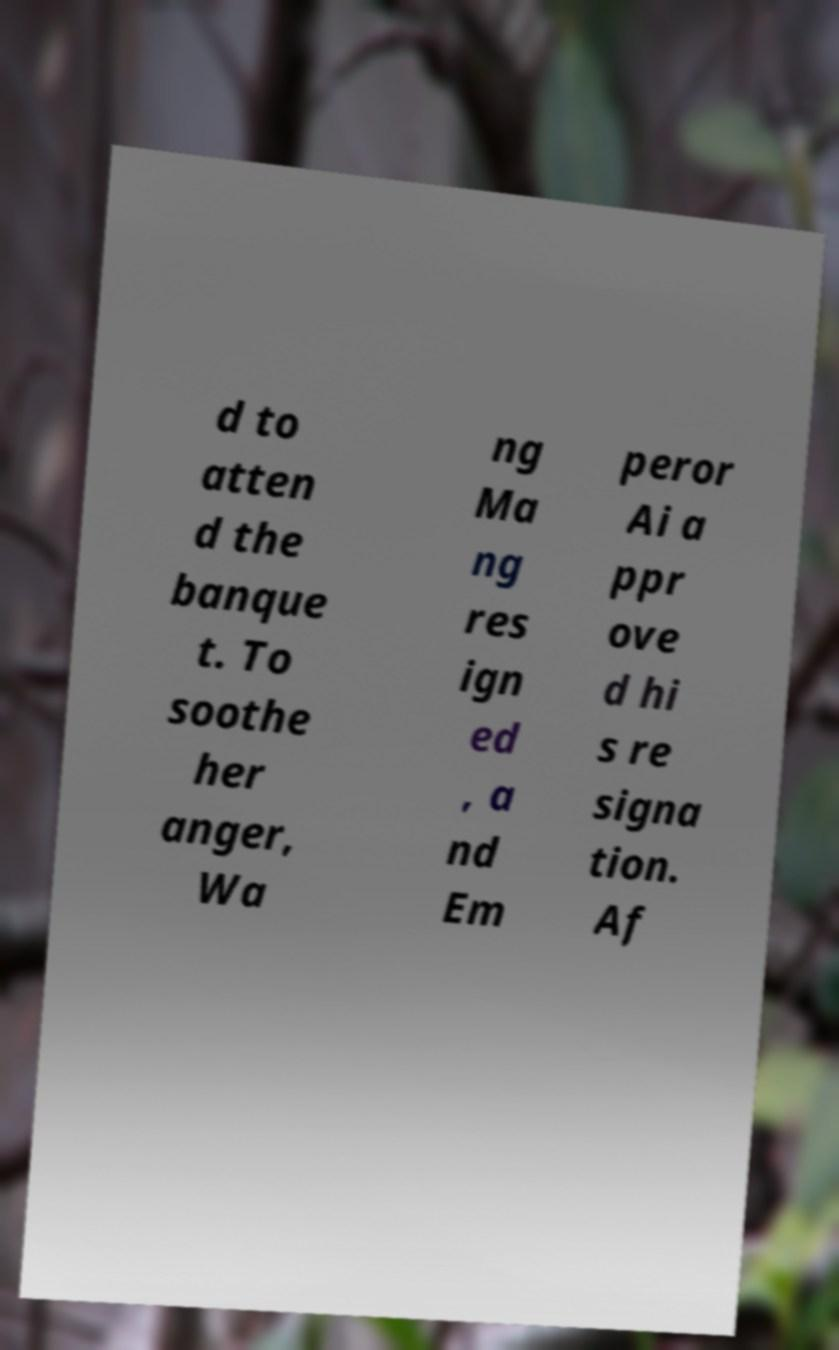For documentation purposes, I need the text within this image transcribed. Could you provide that? d to atten d the banque t. To soothe her anger, Wa ng Ma ng res ign ed , a nd Em peror Ai a ppr ove d hi s re signa tion. Af 